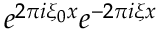<formula> <loc_0><loc_0><loc_500><loc_500>e ^ { 2 \pi i \xi _ { 0 } x } e ^ { - 2 \pi i \xi x }</formula> 